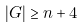Convert formula to latex. <formula><loc_0><loc_0><loc_500><loc_500>| G | \geq n + 4</formula> 